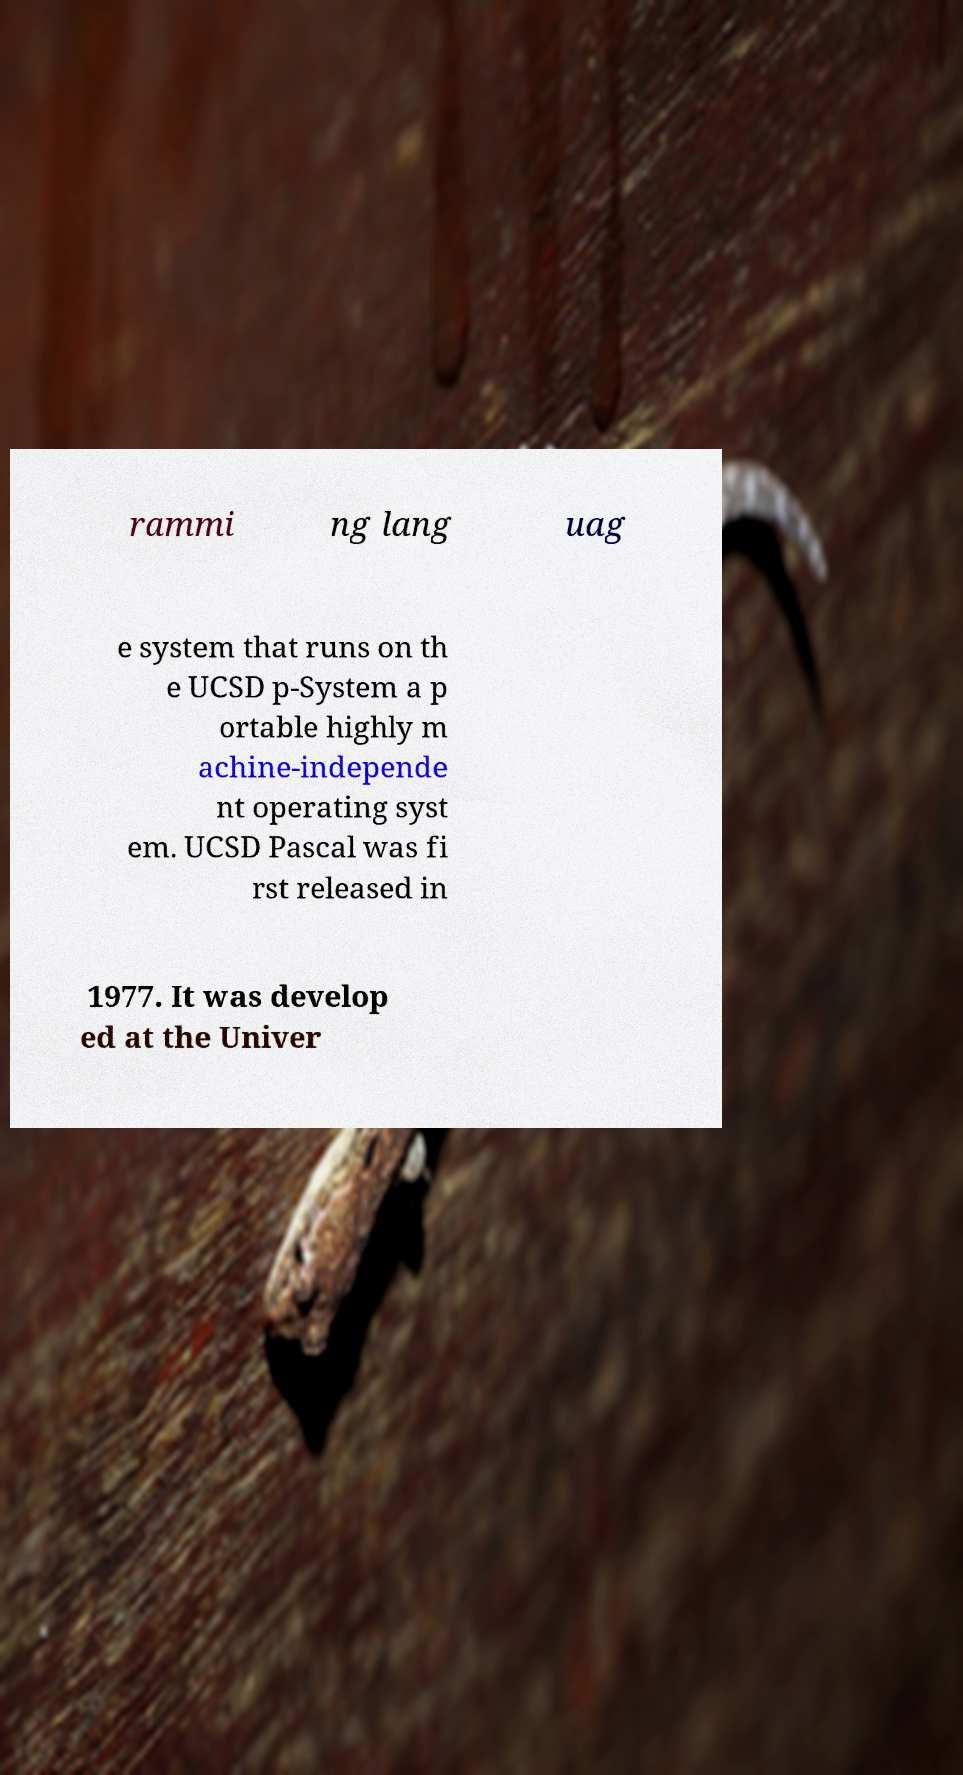Can you accurately transcribe the text from the provided image for me? rammi ng lang uag e system that runs on th e UCSD p-System a p ortable highly m achine-independe nt operating syst em. UCSD Pascal was fi rst released in 1977. It was develop ed at the Univer 